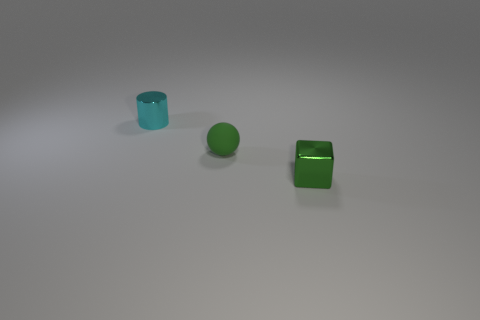Add 2 red shiny cylinders. How many objects exist? 5 Subtract all purple balls. How many red blocks are left? 0 Subtract 1 balls. How many balls are left? 0 Subtract all green cylinders. Subtract all cyan spheres. How many cylinders are left? 1 Subtract all green cubes. Subtract all metal cylinders. How many objects are left? 1 Add 2 small metal cylinders. How many small metal cylinders are left? 3 Add 2 tiny green rubber things. How many tiny green rubber things exist? 3 Subtract 0 purple cubes. How many objects are left? 3 Subtract all spheres. How many objects are left? 2 